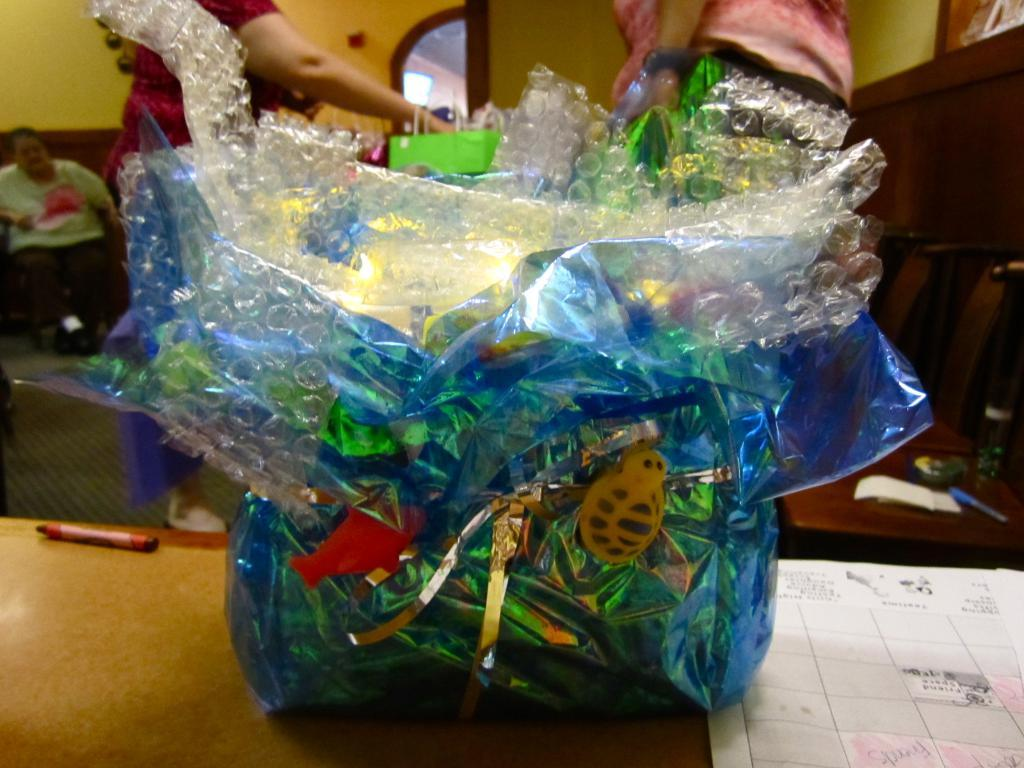What can be seen in the image? There is a gift in the image. Can you describe the appearance of the gift? The gift has a blue packing cover. What type of muscle is visible in the image? There is no muscle visible in the image; it features a gift with a blue packing cover. 